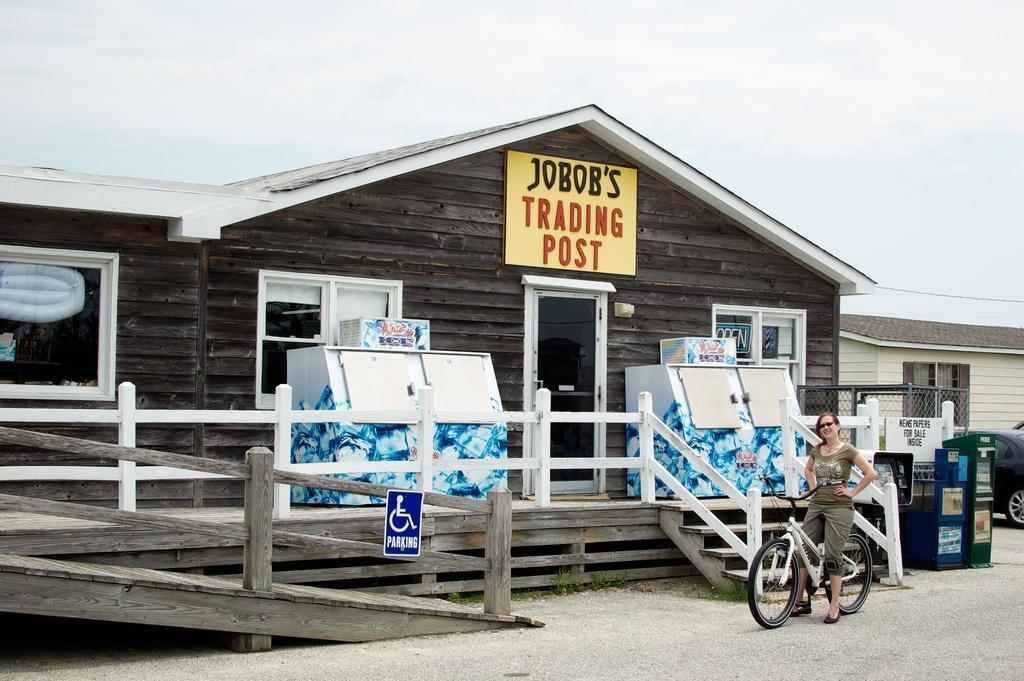Describe this image in one or two sentences. In this picture there is a bamboo house at the left side of the image on which it is written as trading post, there is a lady on a cycle who is standing at the right side of the image. 